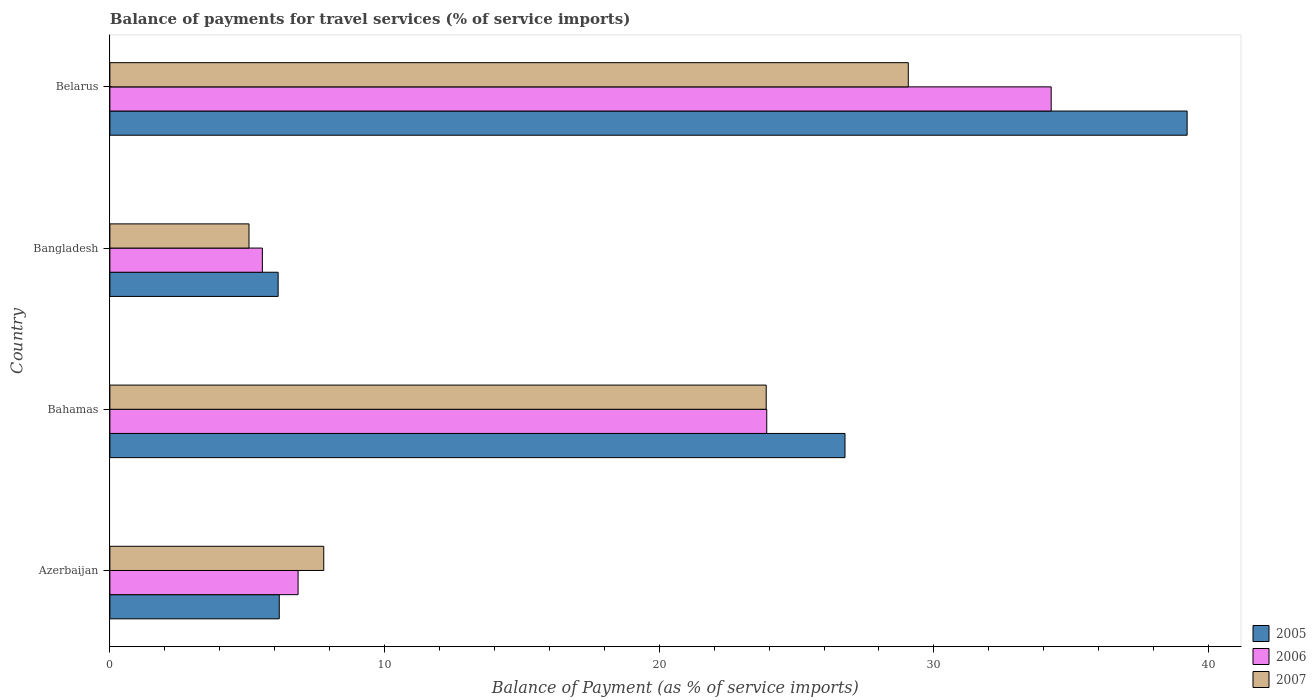How many different coloured bars are there?
Offer a terse response. 3. How many groups of bars are there?
Ensure brevity in your answer.  4. Are the number of bars per tick equal to the number of legend labels?
Give a very brief answer. Yes. How many bars are there on the 1st tick from the bottom?
Your response must be concise. 3. What is the label of the 4th group of bars from the top?
Provide a succinct answer. Azerbaijan. What is the balance of payments for travel services in 2005 in Bahamas?
Your answer should be compact. 26.76. Across all countries, what is the maximum balance of payments for travel services in 2006?
Your response must be concise. 34.27. Across all countries, what is the minimum balance of payments for travel services in 2005?
Give a very brief answer. 6.13. In which country was the balance of payments for travel services in 2007 maximum?
Give a very brief answer. Belarus. In which country was the balance of payments for travel services in 2006 minimum?
Provide a succinct answer. Bangladesh. What is the total balance of payments for travel services in 2005 in the graph?
Offer a very short reply. 78.28. What is the difference between the balance of payments for travel services in 2007 in Azerbaijan and that in Bangladesh?
Offer a very short reply. 2.72. What is the difference between the balance of payments for travel services in 2006 in Bahamas and the balance of payments for travel services in 2005 in Belarus?
Keep it short and to the point. -15.3. What is the average balance of payments for travel services in 2007 per country?
Ensure brevity in your answer.  16.45. What is the difference between the balance of payments for travel services in 2006 and balance of payments for travel services in 2007 in Belarus?
Make the answer very short. 5.2. What is the ratio of the balance of payments for travel services in 2007 in Azerbaijan to that in Bahamas?
Your answer should be very brief. 0.33. Is the balance of payments for travel services in 2005 in Azerbaijan less than that in Bahamas?
Offer a terse response. Yes. Is the difference between the balance of payments for travel services in 2006 in Azerbaijan and Belarus greater than the difference between the balance of payments for travel services in 2007 in Azerbaijan and Belarus?
Keep it short and to the point. No. What is the difference between the highest and the second highest balance of payments for travel services in 2006?
Provide a short and direct response. 10.36. What is the difference between the highest and the lowest balance of payments for travel services in 2007?
Provide a succinct answer. 24. Is the sum of the balance of payments for travel services in 2005 in Bahamas and Belarus greater than the maximum balance of payments for travel services in 2006 across all countries?
Provide a short and direct response. Yes. Are all the bars in the graph horizontal?
Your answer should be very brief. Yes. How many countries are there in the graph?
Your response must be concise. 4. Are the values on the major ticks of X-axis written in scientific E-notation?
Your answer should be compact. No. Does the graph contain any zero values?
Make the answer very short. No. Does the graph contain grids?
Your response must be concise. No. Where does the legend appear in the graph?
Provide a succinct answer. Bottom right. How many legend labels are there?
Offer a very short reply. 3. How are the legend labels stacked?
Ensure brevity in your answer.  Vertical. What is the title of the graph?
Provide a short and direct response. Balance of payments for travel services (% of service imports). What is the label or title of the X-axis?
Ensure brevity in your answer.  Balance of Payment (as % of service imports). What is the Balance of Payment (as % of service imports) of 2005 in Azerbaijan?
Keep it short and to the point. 6.17. What is the Balance of Payment (as % of service imports) in 2006 in Azerbaijan?
Your answer should be compact. 6.85. What is the Balance of Payment (as % of service imports) in 2007 in Azerbaijan?
Your answer should be very brief. 7.79. What is the Balance of Payment (as % of service imports) of 2005 in Bahamas?
Keep it short and to the point. 26.76. What is the Balance of Payment (as % of service imports) in 2006 in Bahamas?
Keep it short and to the point. 23.92. What is the Balance of Payment (as % of service imports) in 2007 in Bahamas?
Provide a short and direct response. 23.89. What is the Balance of Payment (as % of service imports) in 2005 in Bangladesh?
Keep it short and to the point. 6.13. What is the Balance of Payment (as % of service imports) of 2006 in Bangladesh?
Your response must be concise. 5.55. What is the Balance of Payment (as % of service imports) in 2007 in Bangladesh?
Your answer should be compact. 5.06. What is the Balance of Payment (as % of service imports) of 2005 in Belarus?
Offer a terse response. 39.22. What is the Balance of Payment (as % of service imports) of 2006 in Belarus?
Your answer should be very brief. 34.27. What is the Balance of Payment (as % of service imports) of 2007 in Belarus?
Give a very brief answer. 29.07. Across all countries, what is the maximum Balance of Payment (as % of service imports) in 2005?
Ensure brevity in your answer.  39.22. Across all countries, what is the maximum Balance of Payment (as % of service imports) of 2006?
Your answer should be compact. 34.27. Across all countries, what is the maximum Balance of Payment (as % of service imports) in 2007?
Offer a terse response. 29.07. Across all countries, what is the minimum Balance of Payment (as % of service imports) in 2005?
Provide a short and direct response. 6.13. Across all countries, what is the minimum Balance of Payment (as % of service imports) in 2006?
Make the answer very short. 5.55. Across all countries, what is the minimum Balance of Payment (as % of service imports) in 2007?
Your answer should be very brief. 5.06. What is the total Balance of Payment (as % of service imports) of 2005 in the graph?
Provide a short and direct response. 78.28. What is the total Balance of Payment (as % of service imports) of 2006 in the graph?
Provide a succinct answer. 70.59. What is the total Balance of Payment (as % of service imports) in 2007 in the graph?
Provide a short and direct response. 65.81. What is the difference between the Balance of Payment (as % of service imports) in 2005 in Azerbaijan and that in Bahamas?
Your answer should be compact. -20.6. What is the difference between the Balance of Payment (as % of service imports) in 2006 in Azerbaijan and that in Bahamas?
Make the answer very short. -17.06. What is the difference between the Balance of Payment (as % of service imports) of 2007 in Azerbaijan and that in Bahamas?
Your response must be concise. -16.11. What is the difference between the Balance of Payment (as % of service imports) in 2005 in Azerbaijan and that in Bangladesh?
Provide a succinct answer. 0.04. What is the difference between the Balance of Payment (as % of service imports) in 2006 in Azerbaijan and that in Bangladesh?
Make the answer very short. 1.3. What is the difference between the Balance of Payment (as % of service imports) in 2007 in Azerbaijan and that in Bangladesh?
Ensure brevity in your answer.  2.72. What is the difference between the Balance of Payment (as % of service imports) of 2005 in Azerbaijan and that in Belarus?
Offer a very short reply. -33.05. What is the difference between the Balance of Payment (as % of service imports) in 2006 in Azerbaijan and that in Belarus?
Ensure brevity in your answer.  -27.42. What is the difference between the Balance of Payment (as % of service imports) in 2007 in Azerbaijan and that in Belarus?
Your response must be concise. -21.28. What is the difference between the Balance of Payment (as % of service imports) in 2005 in Bahamas and that in Bangladesh?
Give a very brief answer. 20.64. What is the difference between the Balance of Payment (as % of service imports) in 2006 in Bahamas and that in Bangladesh?
Your answer should be very brief. 18.36. What is the difference between the Balance of Payment (as % of service imports) of 2007 in Bahamas and that in Bangladesh?
Give a very brief answer. 18.83. What is the difference between the Balance of Payment (as % of service imports) of 2005 in Bahamas and that in Belarus?
Keep it short and to the point. -12.46. What is the difference between the Balance of Payment (as % of service imports) in 2006 in Bahamas and that in Belarus?
Keep it short and to the point. -10.36. What is the difference between the Balance of Payment (as % of service imports) in 2007 in Bahamas and that in Belarus?
Your response must be concise. -5.17. What is the difference between the Balance of Payment (as % of service imports) of 2005 in Bangladesh and that in Belarus?
Give a very brief answer. -33.09. What is the difference between the Balance of Payment (as % of service imports) of 2006 in Bangladesh and that in Belarus?
Ensure brevity in your answer.  -28.72. What is the difference between the Balance of Payment (as % of service imports) in 2007 in Bangladesh and that in Belarus?
Provide a succinct answer. -24. What is the difference between the Balance of Payment (as % of service imports) in 2005 in Azerbaijan and the Balance of Payment (as % of service imports) in 2006 in Bahamas?
Make the answer very short. -17.75. What is the difference between the Balance of Payment (as % of service imports) in 2005 in Azerbaijan and the Balance of Payment (as % of service imports) in 2007 in Bahamas?
Offer a very short reply. -17.73. What is the difference between the Balance of Payment (as % of service imports) of 2006 in Azerbaijan and the Balance of Payment (as % of service imports) of 2007 in Bahamas?
Make the answer very short. -17.04. What is the difference between the Balance of Payment (as % of service imports) of 2005 in Azerbaijan and the Balance of Payment (as % of service imports) of 2006 in Bangladesh?
Keep it short and to the point. 0.61. What is the difference between the Balance of Payment (as % of service imports) of 2005 in Azerbaijan and the Balance of Payment (as % of service imports) of 2007 in Bangladesh?
Offer a terse response. 1.1. What is the difference between the Balance of Payment (as % of service imports) in 2006 in Azerbaijan and the Balance of Payment (as % of service imports) in 2007 in Bangladesh?
Make the answer very short. 1.79. What is the difference between the Balance of Payment (as % of service imports) of 2005 in Azerbaijan and the Balance of Payment (as % of service imports) of 2006 in Belarus?
Your response must be concise. -28.1. What is the difference between the Balance of Payment (as % of service imports) in 2005 in Azerbaijan and the Balance of Payment (as % of service imports) in 2007 in Belarus?
Your answer should be very brief. -22.9. What is the difference between the Balance of Payment (as % of service imports) in 2006 in Azerbaijan and the Balance of Payment (as % of service imports) in 2007 in Belarus?
Ensure brevity in your answer.  -22.22. What is the difference between the Balance of Payment (as % of service imports) of 2005 in Bahamas and the Balance of Payment (as % of service imports) of 2006 in Bangladesh?
Give a very brief answer. 21.21. What is the difference between the Balance of Payment (as % of service imports) in 2005 in Bahamas and the Balance of Payment (as % of service imports) in 2007 in Bangladesh?
Provide a short and direct response. 21.7. What is the difference between the Balance of Payment (as % of service imports) of 2006 in Bahamas and the Balance of Payment (as % of service imports) of 2007 in Bangladesh?
Give a very brief answer. 18.85. What is the difference between the Balance of Payment (as % of service imports) of 2005 in Bahamas and the Balance of Payment (as % of service imports) of 2006 in Belarus?
Your response must be concise. -7.51. What is the difference between the Balance of Payment (as % of service imports) of 2005 in Bahamas and the Balance of Payment (as % of service imports) of 2007 in Belarus?
Your answer should be very brief. -2.3. What is the difference between the Balance of Payment (as % of service imports) in 2006 in Bahamas and the Balance of Payment (as % of service imports) in 2007 in Belarus?
Provide a succinct answer. -5.15. What is the difference between the Balance of Payment (as % of service imports) in 2005 in Bangladesh and the Balance of Payment (as % of service imports) in 2006 in Belarus?
Provide a short and direct response. -28.14. What is the difference between the Balance of Payment (as % of service imports) of 2005 in Bangladesh and the Balance of Payment (as % of service imports) of 2007 in Belarus?
Make the answer very short. -22.94. What is the difference between the Balance of Payment (as % of service imports) in 2006 in Bangladesh and the Balance of Payment (as % of service imports) in 2007 in Belarus?
Your answer should be compact. -23.52. What is the average Balance of Payment (as % of service imports) in 2005 per country?
Provide a short and direct response. 19.57. What is the average Balance of Payment (as % of service imports) of 2006 per country?
Your response must be concise. 17.65. What is the average Balance of Payment (as % of service imports) of 2007 per country?
Provide a short and direct response. 16.45. What is the difference between the Balance of Payment (as % of service imports) in 2005 and Balance of Payment (as % of service imports) in 2006 in Azerbaijan?
Offer a very short reply. -0.69. What is the difference between the Balance of Payment (as % of service imports) in 2005 and Balance of Payment (as % of service imports) in 2007 in Azerbaijan?
Keep it short and to the point. -1.62. What is the difference between the Balance of Payment (as % of service imports) in 2006 and Balance of Payment (as % of service imports) in 2007 in Azerbaijan?
Your answer should be very brief. -0.93. What is the difference between the Balance of Payment (as % of service imports) in 2005 and Balance of Payment (as % of service imports) in 2006 in Bahamas?
Your response must be concise. 2.85. What is the difference between the Balance of Payment (as % of service imports) in 2005 and Balance of Payment (as % of service imports) in 2007 in Bahamas?
Offer a very short reply. 2.87. What is the difference between the Balance of Payment (as % of service imports) of 2006 and Balance of Payment (as % of service imports) of 2007 in Bahamas?
Keep it short and to the point. 0.02. What is the difference between the Balance of Payment (as % of service imports) of 2005 and Balance of Payment (as % of service imports) of 2006 in Bangladesh?
Keep it short and to the point. 0.57. What is the difference between the Balance of Payment (as % of service imports) in 2005 and Balance of Payment (as % of service imports) in 2007 in Bangladesh?
Offer a very short reply. 1.06. What is the difference between the Balance of Payment (as % of service imports) in 2006 and Balance of Payment (as % of service imports) in 2007 in Bangladesh?
Ensure brevity in your answer.  0.49. What is the difference between the Balance of Payment (as % of service imports) of 2005 and Balance of Payment (as % of service imports) of 2006 in Belarus?
Offer a very short reply. 4.95. What is the difference between the Balance of Payment (as % of service imports) of 2005 and Balance of Payment (as % of service imports) of 2007 in Belarus?
Keep it short and to the point. 10.15. What is the difference between the Balance of Payment (as % of service imports) in 2006 and Balance of Payment (as % of service imports) in 2007 in Belarus?
Provide a succinct answer. 5.2. What is the ratio of the Balance of Payment (as % of service imports) of 2005 in Azerbaijan to that in Bahamas?
Offer a very short reply. 0.23. What is the ratio of the Balance of Payment (as % of service imports) in 2006 in Azerbaijan to that in Bahamas?
Make the answer very short. 0.29. What is the ratio of the Balance of Payment (as % of service imports) in 2007 in Azerbaijan to that in Bahamas?
Your answer should be compact. 0.33. What is the ratio of the Balance of Payment (as % of service imports) in 2006 in Azerbaijan to that in Bangladesh?
Give a very brief answer. 1.23. What is the ratio of the Balance of Payment (as % of service imports) of 2007 in Azerbaijan to that in Bangladesh?
Give a very brief answer. 1.54. What is the ratio of the Balance of Payment (as % of service imports) of 2005 in Azerbaijan to that in Belarus?
Your response must be concise. 0.16. What is the ratio of the Balance of Payment (as % of service imports) of 2006 in Azerbaijan to that in Belarus?
Give a very brief answer. 0.2. What is the ratio of the Balance of Payment (as % of service imports) of 2007 in Azerbaijan to that in Belarus?
Your answer should be very brief. 0.27. What is the ratio of the Balance of Payment (as % of service imports) of 2005 in Bahamas to that in Bangladesh?
Give a very brief answer. 4.37. What is the ratio of the Balance of Payment (as % of service imports) in 2006 in Bahamas to that in Bangladesh?
Keep it short and to the point. 4.31. What is the ratio of the Balance of Payment (as % of service imports) of 2007 in Bahamas to that in Bangladesh?
Keep it short and to the point. 4.72. What is the ratio of the Balance of Payment (as % of service imports) in 2005 in Bahamas to that in Belarus?
Your answer should be compact. 0.68. What is the ratio of the Balance of Payment (as % of service imports) in 2006 in Bahamas to that in Belarus?
Make the answer very short. 0.7. What is the ratio of the Balance of Payment (as % of service imports) of 2007 in Bahamas to that in Belarus?
Your response must be concise. 0.82. What is the ratio of the Balance of Payment (as % of service imports) of 2005 in Bangladesh to that in Belarus?
Offer a very short reply. 0.16. What is the ratio of the Balance of Payment (as % of service imports) of 2006 in Bangladesh to that in Belarus?
Provide a succinct answer. 0.16. What is the ratio of the Balance of Payment (as % of service imports) of 2007 in Bangladesh to that in Belarus?
Keep it short and to the point. 0.17. What is the difference between the highest and the second highest Balance of Payment (as % of service imports) of 2005?
Provide a succinct answer. 12.46. What is the difference between the highest and the second highest Balance of Payment (as % of service imports) in 2006?
Offer a very short reply. 10.36. What is the difference between the highest and the second highest Balance of Payment (as % of service imports) of 2007?
Provide a succinct answer. 5.17. What is the difference between the highest and the lowest Balance of Payment (as % of service imports) in 2005?
Offer a terse response. 33.09. What is the difference between the highest and the lowest Balance of Payment (as % of service imports) of 2006?
Your answer should be very brief. 28.72. What is the difference between the highest and the lowest Balance of Payment (as % of service imports) in 2007?
Your response must be concise. 24. 